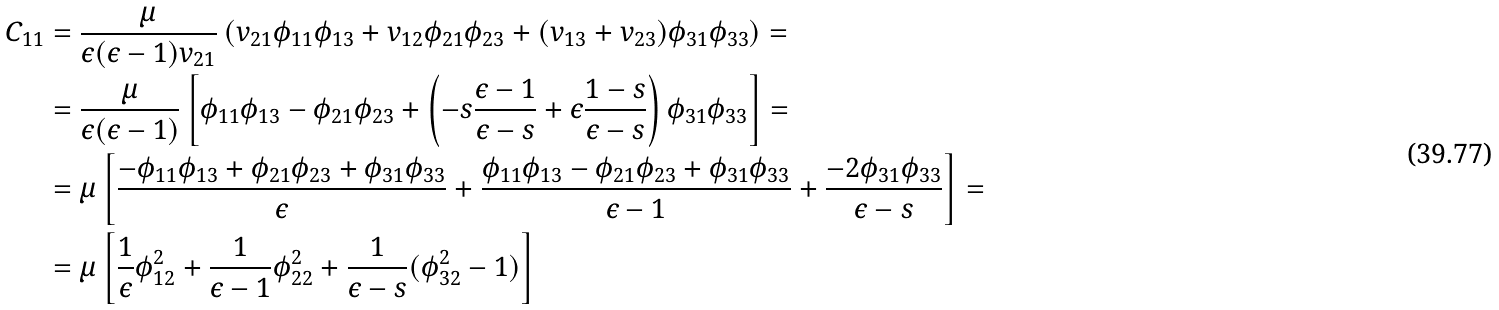<formula> <loc_0><loc_0><loc_500><loc_500>C _ { 1 1 } & = \frac { \mu } { \epsilon ( \epsilon - 1 ) v _ { 2 1 } } \left ( v _ { 2 1 } \phi _ { 1 1 } \phi _ { 1 3 } + v _ { 1 2 } \phi _ { 2 1 } \phi _ { 2 3 } + ( v _ { 1 3 } + v _ { 2 3 } ) \phi _ { 3 1 } \phi _ { 3 3 } \right ) = \\ & = \frac { \mu } { \epsilon ( \epsilon - 1 ) } \left [ \phi _ { 1 1 } \phi _ { 1 3 } - \phi _ { 2 1 } \phi _ { 2 3 } + \left ( - s \frac { \epsilon - 1 } { \epsilon - s } + \epsilon \frac { 1 - s } { \epsilon - s } \right ) \phi _ { 3 1 } \phi _ { 3 3 } \right ] = \\ & = \mu \left [ \frac { - \phi _ { 1 1 } \phi _ { 1 3 } + \phi _ { 2 1 } \phi _ { 2 3 } + \phi _ { 3 1 } \phi _ { 3 3 } } { \epsilon } + \frac { \phi _ { 1 1 } \phi _ { 1 3 } - \phi _ { 2 1 } \phi _ { 2 3 } + \phi _ { 3 1 } \phi _ { 3 3 } } { \epsilon - 1 } + \frac { - 2 \phi _ { 3 1 } \phi _ { 3 3 } } { \epsilon - s } \right ] = \\ & = \mu \left [ \frac { 1 } { \epsilon } \phi _ { 1 2 } ^ { 2 } + \frac { 1 } { \epsilon - 1 } \phi _ { 2 2 } ^ { 2 } + \frac { 1 } { \epsilon - s } ( \phi _ { 3 2 } ^ { 2 } - 1 ) \right ]</formula> 